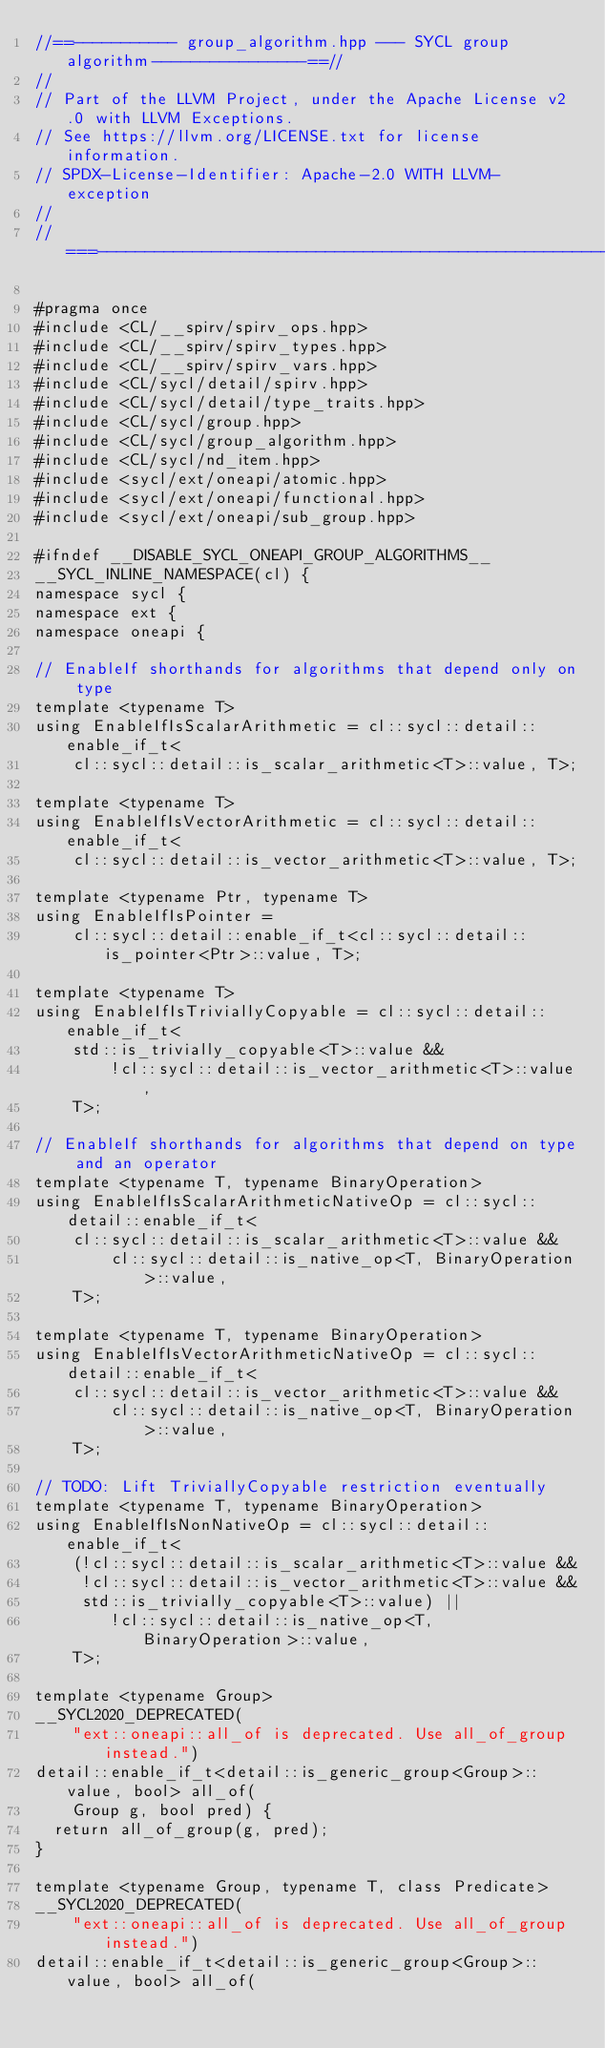Convert code to text. <code><loc_0><loc_0><loc_500><loc_500><_C++_>//==----------- group_algorithm.hpp --- SYCL group algorithm----------------==//
//
// Part of the LLVM Project, under the Apache License v2.0 with LLVM Exceptions.
// See https://llvm.org/LICENSE.txt for license information.
// SPDX-License-Identifier: Apache-2.0 WITH LLVM-exception
//
//===----------------------------------------------------------------------===//

#pragma once
#include <CL/__spirv/spirv_ops.hpp>
#include <CL/__spirv/spirv_types.hpp>
#include <CL/__spirv/spirv_vars.hpp>
#include <CL/sycl/detail/spirv.hpp>
#include <CL/sycl/detail/type_traits.hpp>
#include <CL/sycl/group.hpp>
#include <CL/sycl/group_algorithm.hpp>
#include <CL/sycl/nd_item.hpp>
#include <sycl/ext/oneapi/atomic.hpp>
#include <sycl/ext/oneapi/functional.hpp>
#include <sycl/ext/oneapi/sub_group.hpp>

#ifndef __DISABLE_SYCL_ONEAPI_GROUP_ALGORITHMS__
__SYCL_INLINE_NAMESPACE(cl) {
namespace sycl {
namespace ext {
namespace oneapi {

// EnableIf shorthands for algorithms that depend only on type
template <typename T>
using EnableIfIsScalarArithmetic = cl::sycl::detail::enable_if_t<
    cl::sycl::detail::is_scalar_arithmetic<T>::value, T>;

template <typename T>
using EnableIfIsVectorArithmetic = cl::sycl::detail::enable_if_t<
    cl::sycl::detail::is_vector_arithmetic<T>::value, T>;

template <typename Ptr, typename T>
using EnableIfIsPointer =
    cl::sycl::detail::enable_if_t<cl::sycl::detail::is_pointer<Ptr>::value, T>;

template <typename T>
using EnableIfIsTriviallyCopyable = cl::sycl::detail::enable_if_t<
    std::is_trivially_copyable<T>::value &&
        !cl::sycl::detail::is_vector_arithmetic<T>::value,
    T>;

// EnableIf shorthands for algorithms that depend on type and an operator
template <typename T, typename BinaryOperation>
using EnableIfIsScalarArithmeticNativeOp = cl::sycl::detail::enable_if_t<
    cl::sycl::detail::is_scalar_arithmetic<T>::value &&
        cl::sycl::detail::is_native_op<T, BinaryOperation>::value,
    T>;

template <typename T, typename BinaryOperation>
using EnableIfIsVectorArithmeticNativeOp = cl::sycl::detail::enable_if_t<
    cl::sycl::detail::is_vector_arithmetic<T>::value &&
        cl::sycl::detail::is_native_op<T, BinaryOperation>::value,
    T>;

// TODO: Lift TriviallyCopyable restriction eventually
template <typename T, typename BinaryOperation>
using EnableIfIsNonNativeOp = cl::sycl::detail::enable_if_t<
    (!cl::sycl::detail::is_scalar_arithmetic<T>::value &&
     !cl::sycl::detail::is_vector_arithmetic<T>::value &&
     std::is_trivially_copyable<T>::value) ||
        !cl::sycl::detail::is_native_op<T, BinaryOperation>::value,
    T>;

template <typename Group>
__SYCL2020_DEPRECATED(
    "ext::oneapi::all_of is deprecated. Use all_of_group instead.")
detail::enable_if_t<detail::is_generic_group<Group>::value, bool> all_of(
    Group g, bool pred) {
  return all_of_group(g, pred);
}

template <typename Group, typename T, class Predicate>
__SYCL2020_DEPRECATED(
    "ext::oneapi::all_of is deprecated. Use all_of_group instead.")
detail::enable_if_t<detail::is_generic_group<Group>::value, bool> all_of(</code> 